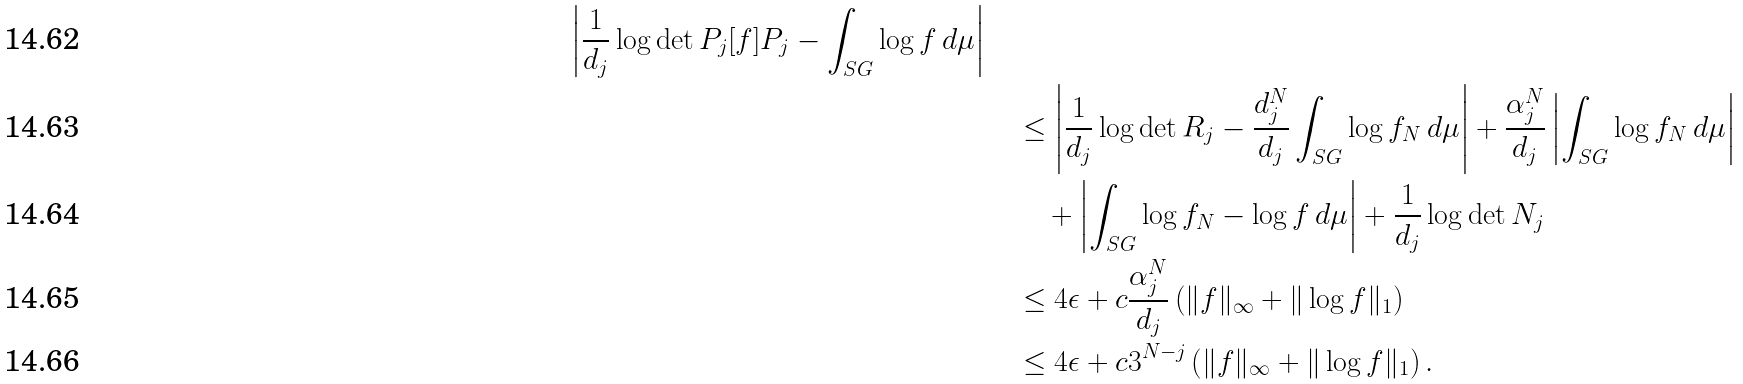Convert formula to latex. <formula><loc_0><loc_0><loc_500><loc_500>{ \left | \frac { 1 } { d _ { j } } \log \det P _ { j } [ f ] P _ { j } - \int _ { S G } \log f \, d \mu \right | } \quad & \\ & \leq \left | \frac { 1 } { d _ { j } } \log \det R _ { j } - \frac { d _ { j } ^ { N } } { d _ { j } } \int _ { S G } \log f _ { N } \, d \mu \right | + \frac { \alpha _ { j } ^ { N } } { d _ { j } } \left | \int _ { S G } \log f _ { N } \, d \mu \right | \\ & \quad + \left | \int _ { S G } \log f _ { N } - \log f \, d \mu \right | + \frac { 1 } { d _ { j } } \log \det N _ { j } \\ & \leq 4 \epsilon + c \frac { \alpha _ { j } ^ { N } } { d _ { j } } \left ( \| f \| _ { \infty } + \| \log f \| _ { 1 } \right ) \\ & \leq 4 \epsilon + c 3 ^ { N - j } \left ( \| f \| _ { \infty } + \| \log f \| _ { 1 } \right ) .</formula> 